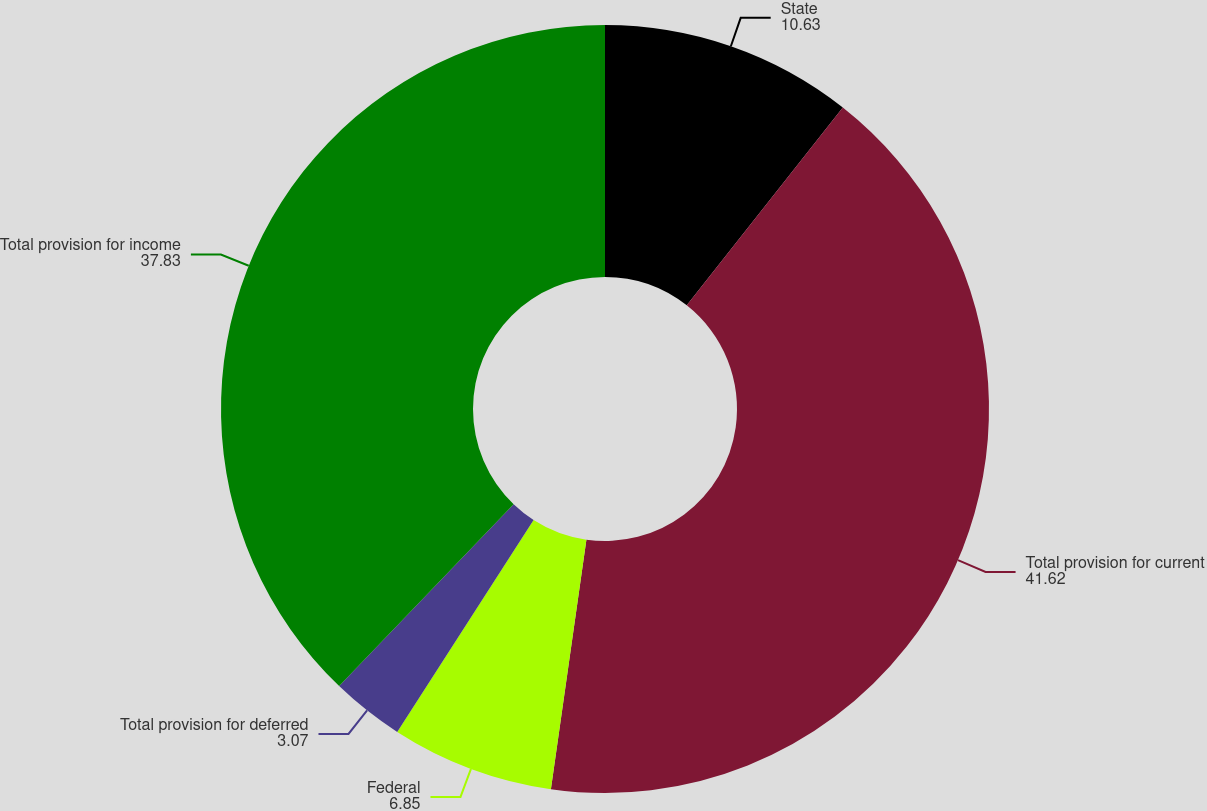Convert chart. <chart><loc_0><loc_0><loc_500><loc_500><pie_chart><fcel>State<fcel>Total provision for current<fcel>Federal<fcel>Total provision for deferred<fcel>Total provision for income<nl><fcel>10.63%<fcel>41.62%<fcel>6.85%<fcel>3.07%<fcel>37.83%<nl></chart> 